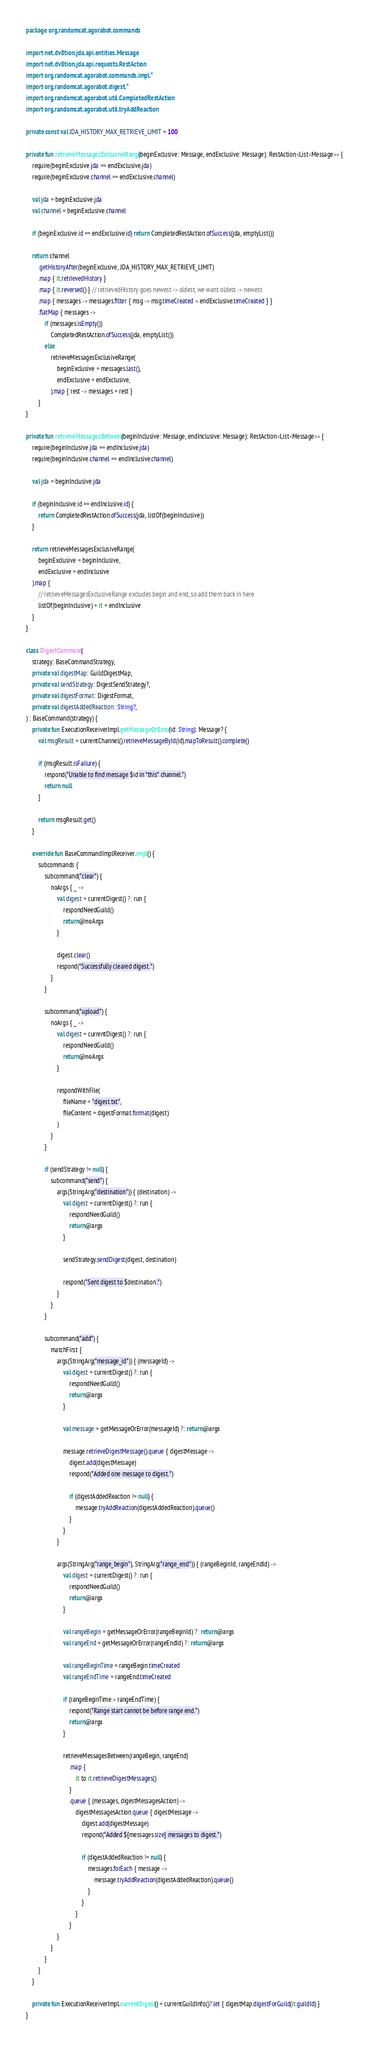Convert code to text. <code><loc_0><loc_0><loc_500><loc_500><_Kotlin_>package org.randomcat.agorabot.commands

import net.dv8tion.jda.api.entities.Message
import net.dv8tion.jda.api.requests.RestAction
import org.randomcat.agorabot.commands.impl.*
import org.randomcat.agorabot.digest.*
import org.randomcat.agorabot.util.CompletedRestAction
import org.randomcat.agorabot.util.tryAddReaction

private const val JDA_HISTORY_MAX_RETRIEVE_LIMIT = 100

private fun retrieveMessagesExclusiveRange(beginExclusive: Message, endExclusive: Message): RestAction<List<Message>> {
    require(beginExclusive.jda == endExclusive.jda)
    require(beginExclusive.channel == endExclusive.channel)

    val jda = beginExclusive.jda
    val channel = beginExclusive.channel

    if (beginExclusive.id == endExclusive.id) return CompletedRestAction.ofSuccess(jda, emptyList())

    return channel
        .getHistoryAfter(beginExclusive, JDA_HISTORY_MAX_RETRIEVE_LIMIT)
        .map { it.retrievedHistory }
        .map { it.reversed() } // retrievedHistory goes newest -> oldest, we want oldest -> newest
        .map { messages -> messages.filter { msg -> msg.timeCreated < endExclusive.timeCreated } }
        .flatMap { messages ->
            if (messages.isEmpty())
                CompletedRestAction.ofSuccess(jda, emptyList())
            else
                retrieveMessagesExclusiveRange(
                    beginExclusive = messages.last(),
                    endExclusive = endExclusive,
                ).map { rest -> messages + rest }
        }
}

private fun retrieveMessagesBetween(beginInclusive: Message, endInclusive: Message): RestAction<List<Message>> {
    require(beginInclusive.jda == endInclusive.jda)
    require(beginInclusive.channel == endInclusive.channel)

    val jda = beginInclusive.jda

    if (beginInclusive.id == endInclusive.id) {
        return CompletedRestAction.ofSuccess(jda, listOf(beginInclusive))
    }

    return retrieveMessagesExclusiveRange(
        beginExclusive = beginInclusive,
        endExclusive = endInclusive
    ).map {
        // retrieveMessagesExclusiveRange excludes begin and end, so add them back in here
        listOf(beginInclusive) + it + endInclusive
    }
}

class DigestCommand(
    strategy: BaseCommandStrategy,
    private val digestMap: GuildDigestMap,
    private val sendStrategy: DigestSendStrategy?,
    private val digestFormat: DigestFormat,
    private val digestAddedReaction: String?,
) : BaseCommand(strategy) {
    private fun ExecutionReceiverImpl.getMessageOrError(id: String): Message? {
        val msgResult = currentChannel().retrieveMessageById(id).mapToResult().complete()

        if (msgResult.isFailure) {
            respond("Unable to find message $id in *this* channel.")
            return null
        }

        return msgResult.get()
    }

    override fun BaseCommandImplReceiver.impl() {
        subcommands {
            subcommand("clear") {
                noArgs { _ ->
                    val digest = currentDigest() ?: run {
                        respondNeedGuild()
                        return@noArgs
                    }

                    digest.clear()
                    respond("Successfully cleared digest.")
                }
            }

            subcommand("upload") {
                noArgs { _ ->
                    val digest = currentDigest() ?: run {
                        respondNeedGuild()
                        return@noArgs
                    }

                    respondWithFile(
                        fileName = "digest.txt",
                        fileContent = digestFormat.format(digest)
                    )
                }
            }

            if (sendStrategy != null) {
                subcommand("send") {
                    args(StringArg("destination")) { (destination) ->
                        val digest = currentDigest() ?: run {
                            respondNeedGuild()
                            return@args
                        }

                        sendStrategy.sendDigest(digest, destination)

                        respond("Sent digest to $destination.")
                    }
                }
            }

            subcommand("add") {
                matchFirst {
                    args(StringArg("message_id")) { (messageId) ->
                        val digest = currentDigest() ?: run {
                            respondNeedGuild()
                            return@args
                        }

                        val message = getMessageOrError(messageId) ?: return@args

                        message.retrieveDigestMessage().queue { digestMessage ->
                            digest.add(digestMessage)
                            respond("Added one message to digest.")

                            if (digestAddedReaction != null) {
                                message.tryAddReaction(digestAddedReaction).queue()
                            }
                        }
                    }

                    args(StringArg("range_begin"), StringArg("range_end")) { (rangeBeginId, rangeEndId) ->
                        val digest = currentDigest() ?: run {
                            respondNeedGuild()
                            return@args
                        }

                        val rangeBegin = getMessageOrError(rangeBeginId) ?: return@args
                        val rangeEnd = getMessageOrError(rangeEndId) ?: return@args

                        val rangeBeginTime = rangeBegin.timeCreated
                        val rangeEndTime = rangeEnd.timeCreated

                        if (rangeBeginTime > rangeEndTime) {
                            respond("Range start cannot be before range end.")
                            return@args
                        }

                        retrieveMessagesBetween(rangeBegin, rangeEnd)
                            .map {
                                it to it.retrieveDigestMessages()
                            }
                            .queue { (messages, digestMessagesAction) ->
                                digestMessagesAction.queue { digestMessage ->
                                    digest.add(digestMessage)
                                    respond("Added ${messages.size} messages to digest.")

                                    if (digestAddedReaction != null) {
                                        messages.forEach { message ->
                                            message.tryAddReaction(digestAddedReaction).queue()
                                        }
                                    }
                                }
                            }
                    }
                }
            }
        }
    }

    private fun ExecutionReceiverImpl.currentDigest() = currentGuildInfo()?.let { digestMap.digestForGuild(it.guildId) }
}
</code> 